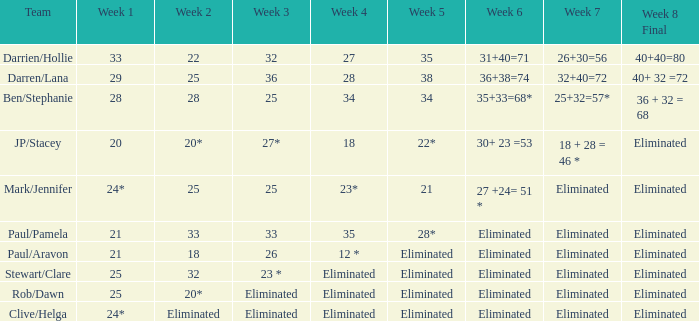Name the week 3 with week 6 of 31+40=71 32.0. 